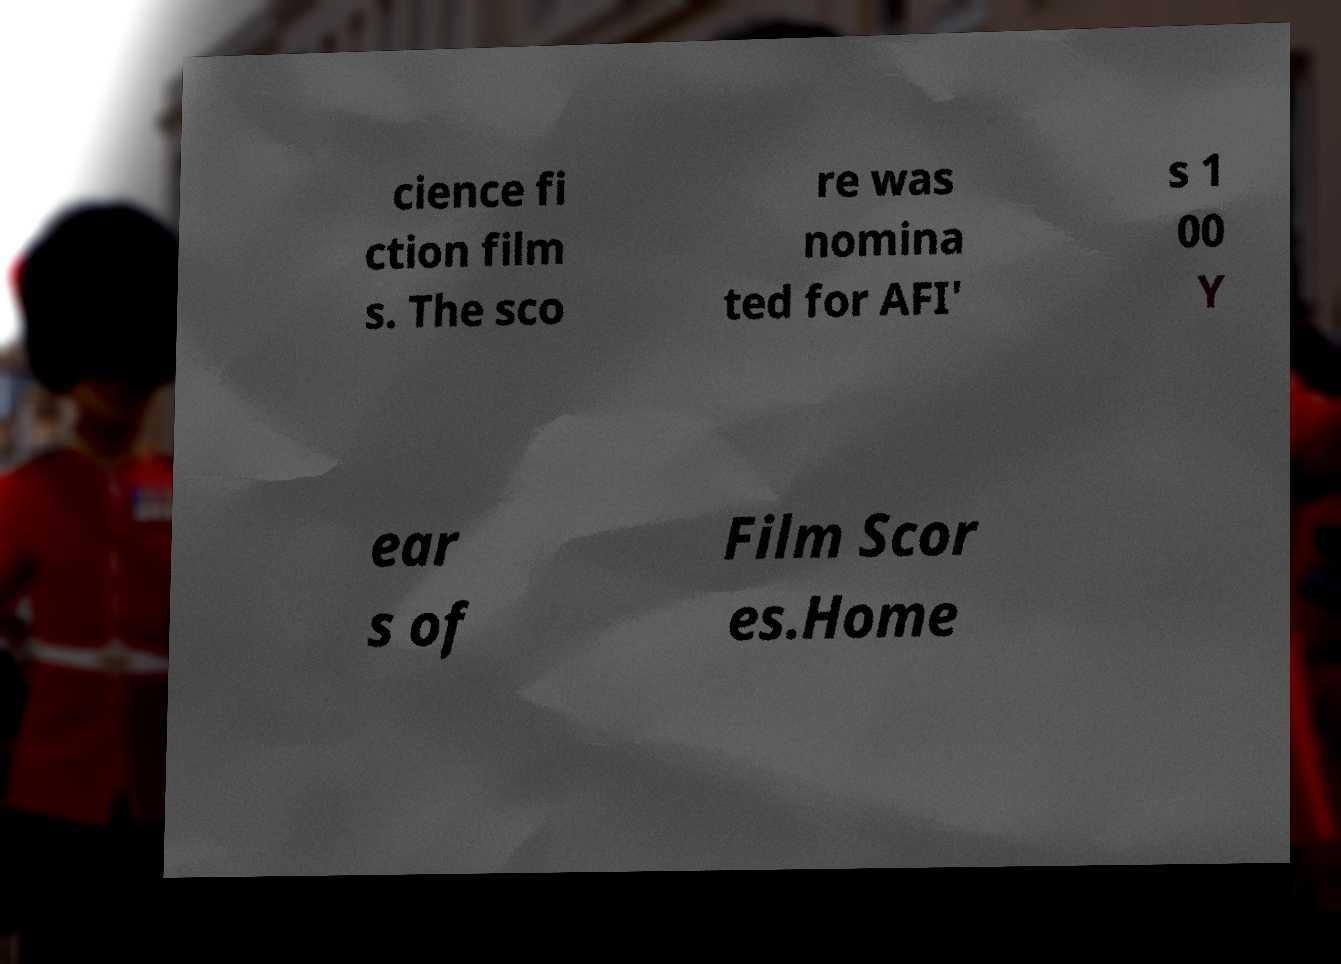Could you extract and type out the text from this image? cience fi ction film s. The sco re was nomina ted for AFI' s 1 00 Y ear s of Film Scor es.Home 